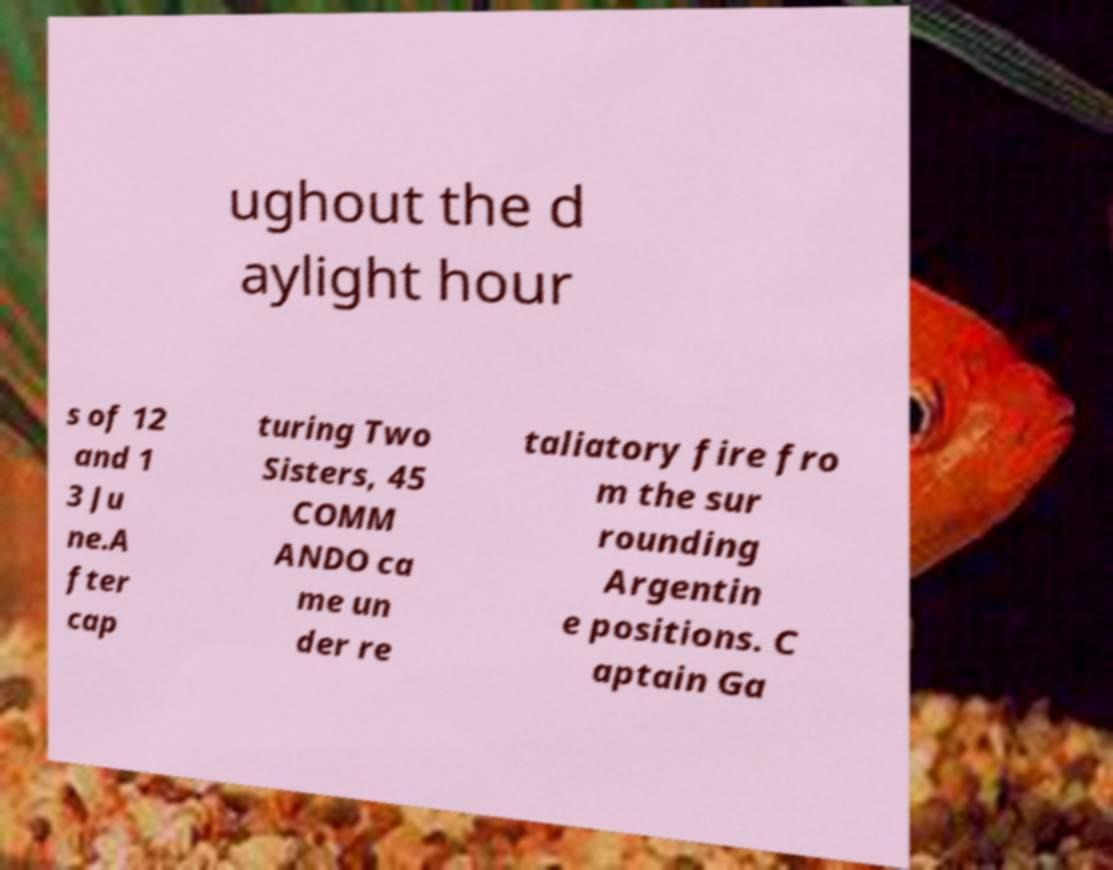Please identify and transcribe the text found in this image. ughout the d aylight hour s of 12 and 1 3 Ju ne.A fter cap turing Two Sisters, 45 COMM ANDO ca me un der re taliatory fire fro m the sur rounding Argentin e positions. C aptain Ga 